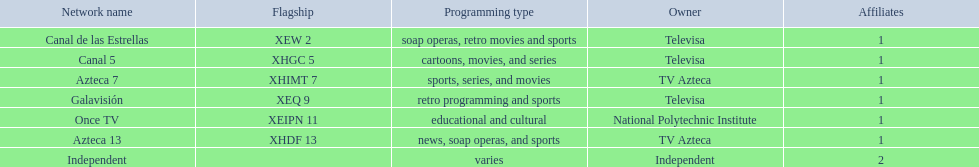What network airs cartoons? Canal 5. What network features soap operas? Canal de las Estrellas. What network showcases sports? Azteca 7. 